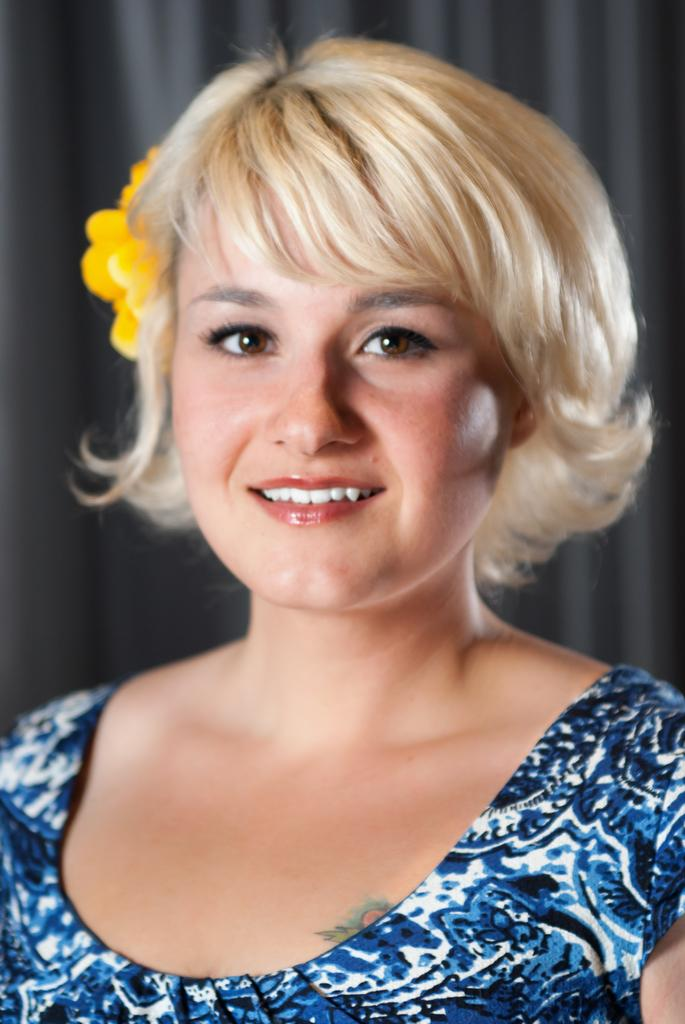Who is the main subject in the image? There is a lady in the image. What is a noticeable detail about the lady's appearance? The lady has a flower in her hair. What can be seen behind the lady in the image? There is a curtain visible behind the lady. How would you describe the background of the image? The background of the image is blurred. What type of corn can be seen growing in the background of the image? There is no corn visible in the image; the background is blurred and does not show any plants or crops. 